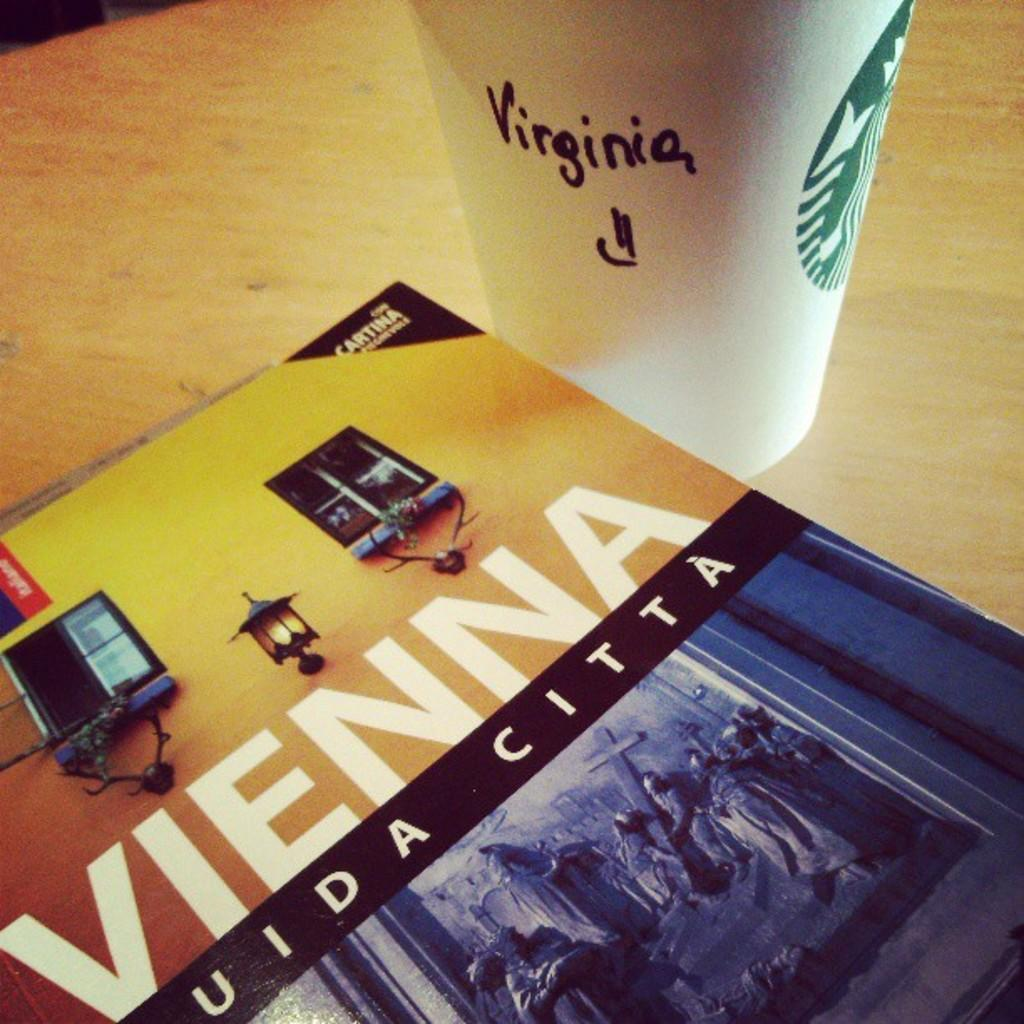<image>
Render a clear and concise summary of the photo. A starbucks coffee cup with Virginia written on the side sits on front of a book called Vienna 